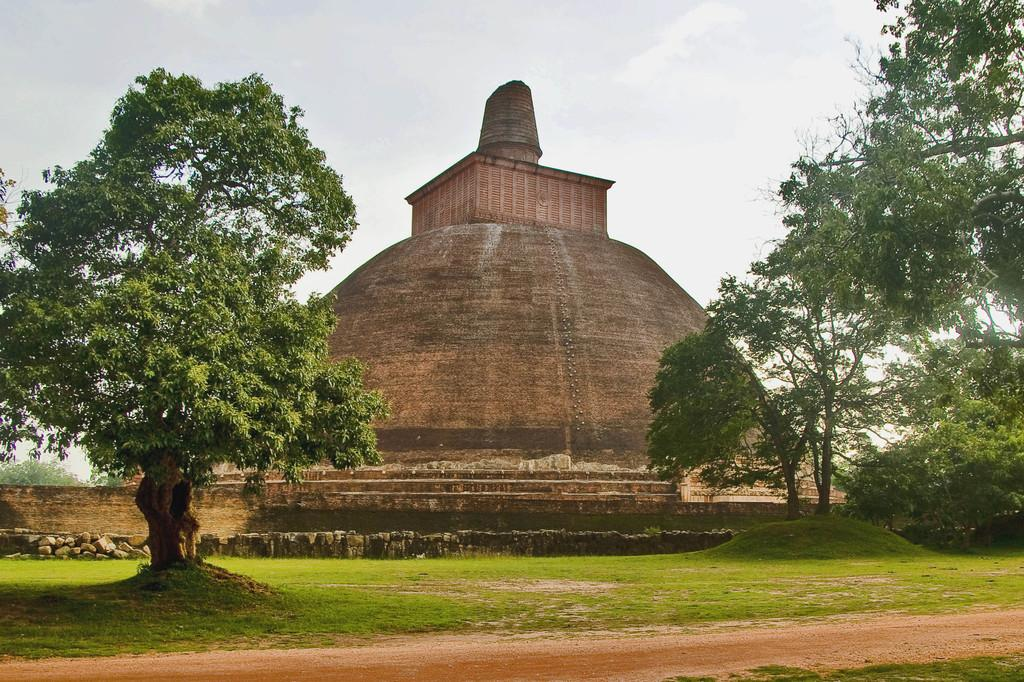What type of landscape is depicted in the image? There is a grassland in the image. What can be seen on the sides of the grassland? Trees are present on either side of the image. What type of structure is visible in the image? There is a stone wall and a stone architecture building in the image. What is visible in the background of the image? The sky is plain and visible in the background of the image. What month is it in the image? The month cannot be determined from the image, as it does not contain any information about the time of year. 